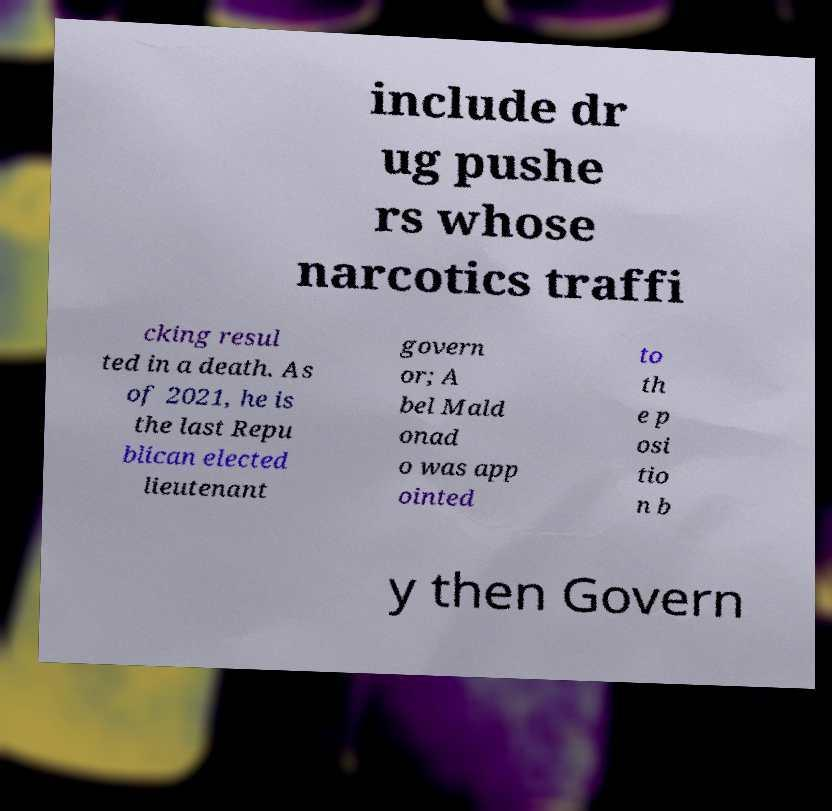What messages or text are displayed in this image? I need them in a readable, typed format. include dr ug pushe rs whose narcotics traffi cking resul ted in a death. As of 2021, he is the last Repu blican elected lieutenant govern or; A bel Mald onad o was app ointed to th e p osi tio n b y then Govern 